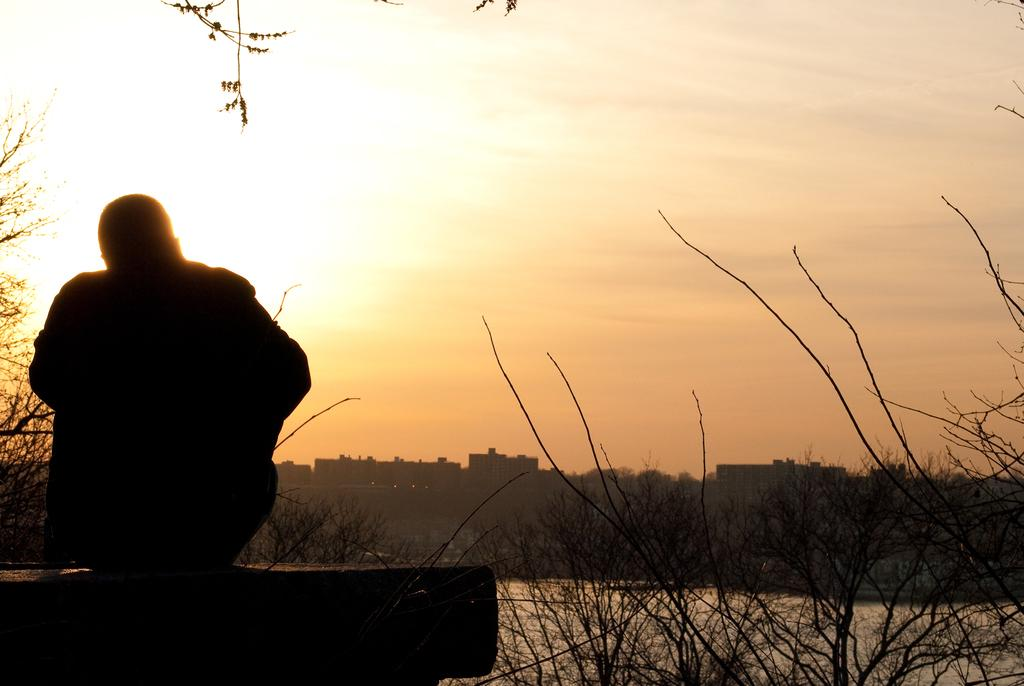What is the person in the image doing? There is a person sitting on a wall in the image. What type of vegetation can be seen on the right side of the image? There are many plants on the right side of the image. What can be seen in the image besides the person and plants? There is water visible in the image. What is visible in the background of the image? There are buildings in the background of the image. What is visible at the top of the image? The sky is visible at the top of the image. What type of yam is being sold in the shop in the image? There is no shop or yam present in the image. What is the servant doing in the image? There is no servant present in the image. 